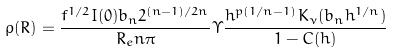Convert formula to latex. <formula><loc_0><loc_0><loc_500><loc_500>\rho ( R ) = \frac { f ^ { 1 / 2 } I ( 0 ) b _ { n } 2 ^ { ( n - 1 ) / 2 n } } { R _ { e } n \pi } \Upsilon \frac { h ^ { p ( 1 / n - 1 ) } K _ { \nu } ( b _ { n } h ^ { 1 / n } ) } { 1 - C ( h ) }</formula> 